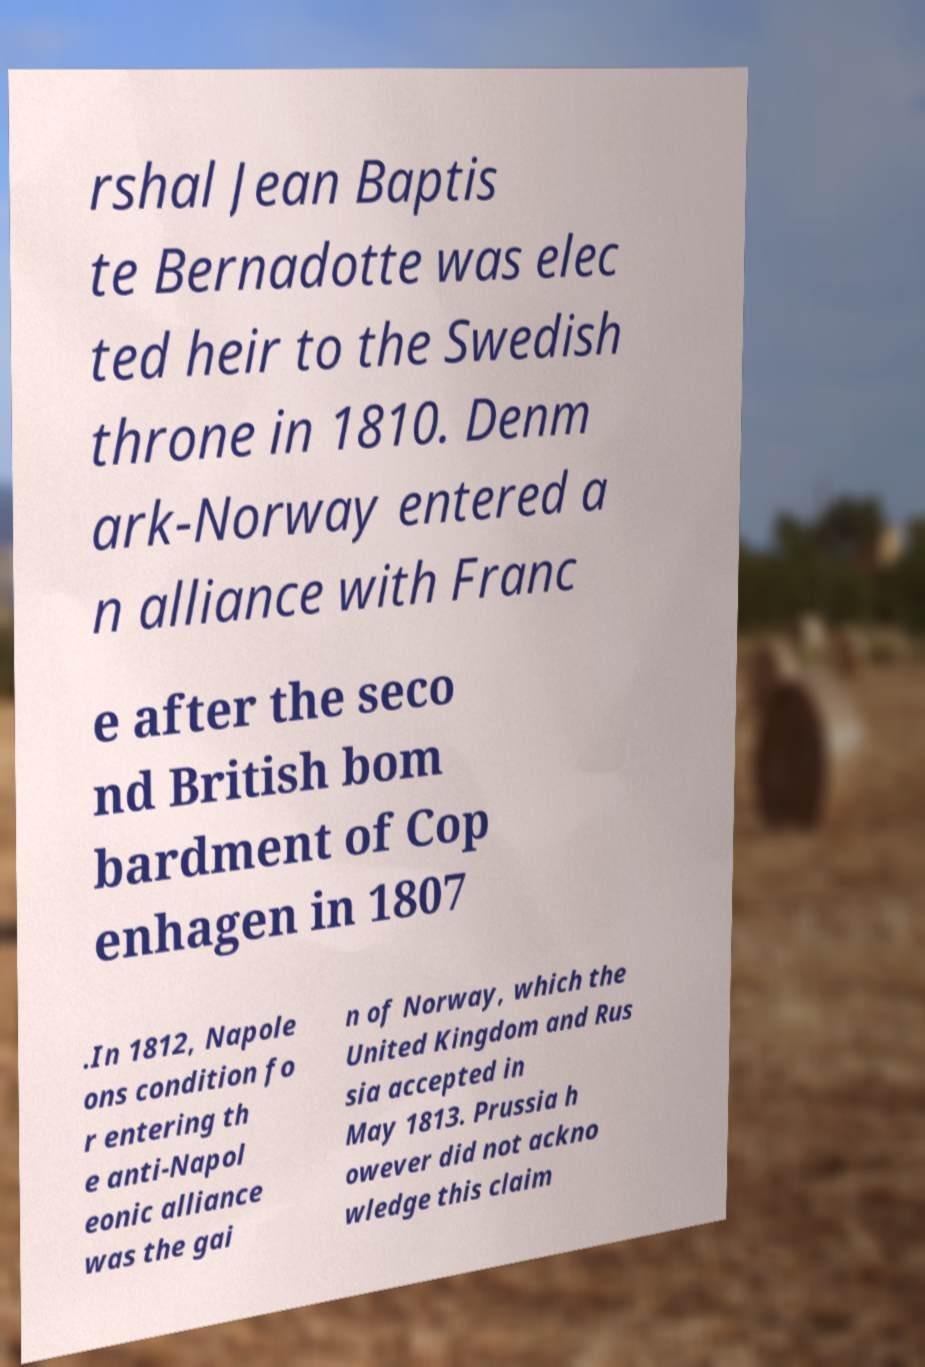I need the written content from this picture converted into text. Can you do that? rshal Jean Baptis te Bernadotte was elec ted heir to the Swedish throne in 1810. Denm ark-Norway entered a n alliance with Franc e after the seco nd British bom bardment of Cop enhagen in 1807 .In 1812, Napole ons condition fo r entering th e anti-Napol eonic alliance was the gai n of Norway, which the United Kingdom and Rus sia accepted in May 1813. Prussia h owever did not ackno wledge this claim 